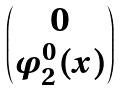<formula> <loc_0><loc_0><loc_500><loc_500>\begin{pmatrix} 0 \\ \varphi ^ { 0 } _ { 2 } ( x ) \end{pmatrix}</formula> 